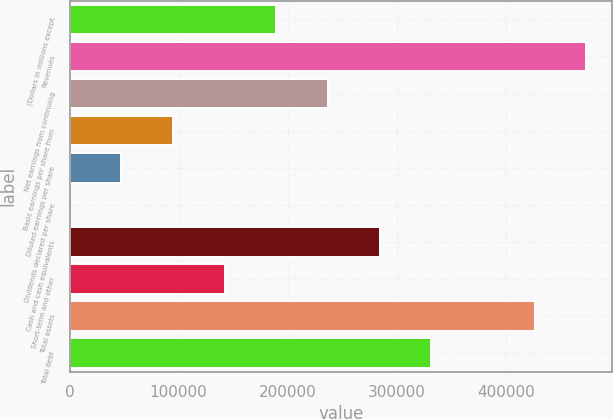<chart> <loc_0><loc_0><loc_500><loc_500><bar_chart><fcel>(Dollars in millions except<fcel>Revenues<fcel>Net earnings from continuing<fcel>Basic earnings per share from<fcel>Diluted earnings per share<fcel>Dividends declared per share<fcel>Cash and cash equivalents<fcel>Short-term and other<fcel>Total assets<fcel>Total debt<nl><fcel>189400<fcel>473492<fcel>236748<fcel>94702.1<fcel>47353.4<fcel>4.69<fcel>284097<fcel>142051<fcel>426143<fcel>331446<nl></chart> 